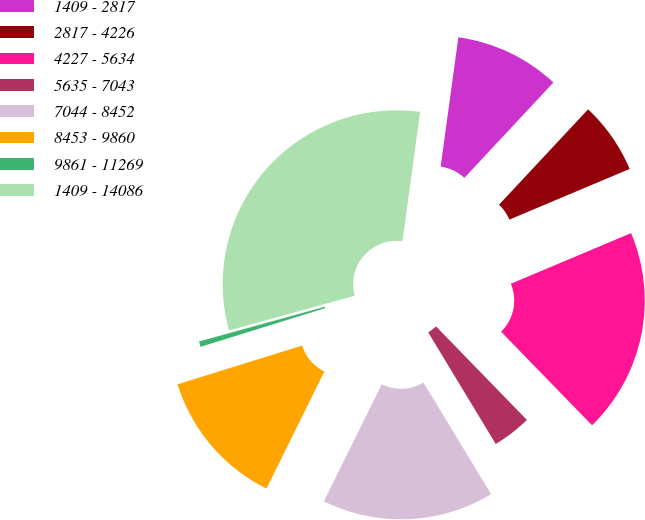Convert chart to OTSL. <chart><loc_0><loc_0><loc_500><loc_500><pie_chart><fcel>1409 - 2817<fcel>2817 - 4226<fcel>4227 - 5634<fcel>5635 - 7043<fcel>7044 - 8452<fcel>8453 - 9860<fcel>9861 - 11269<fcel>1409 - 14086<nl><fcel>9.79%<fcel>6.7%<fcel>19.07%<fcel>3.61%<fcel>15.98%<fcel>12.89%<fcel>0.51%<fcel>31.45%<nl></chart> 